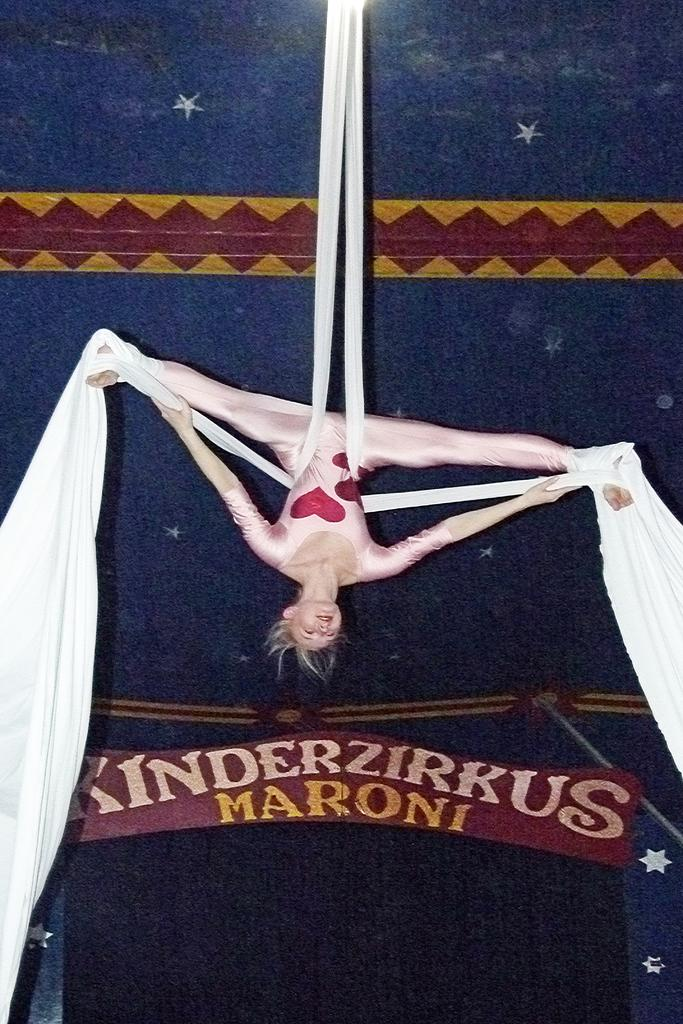What is the main subject of the image? There is a woman in the image. What is the woman doing in the image? The woman is performing acrobatics. How many mice are present in the image? There are no mice present in the image. Does the existence of the woman in the image prove the existence of a higher power? The presence of the woman in the image does not prove the existence of a higher power; it simply shows a woman performing acrobatics. 